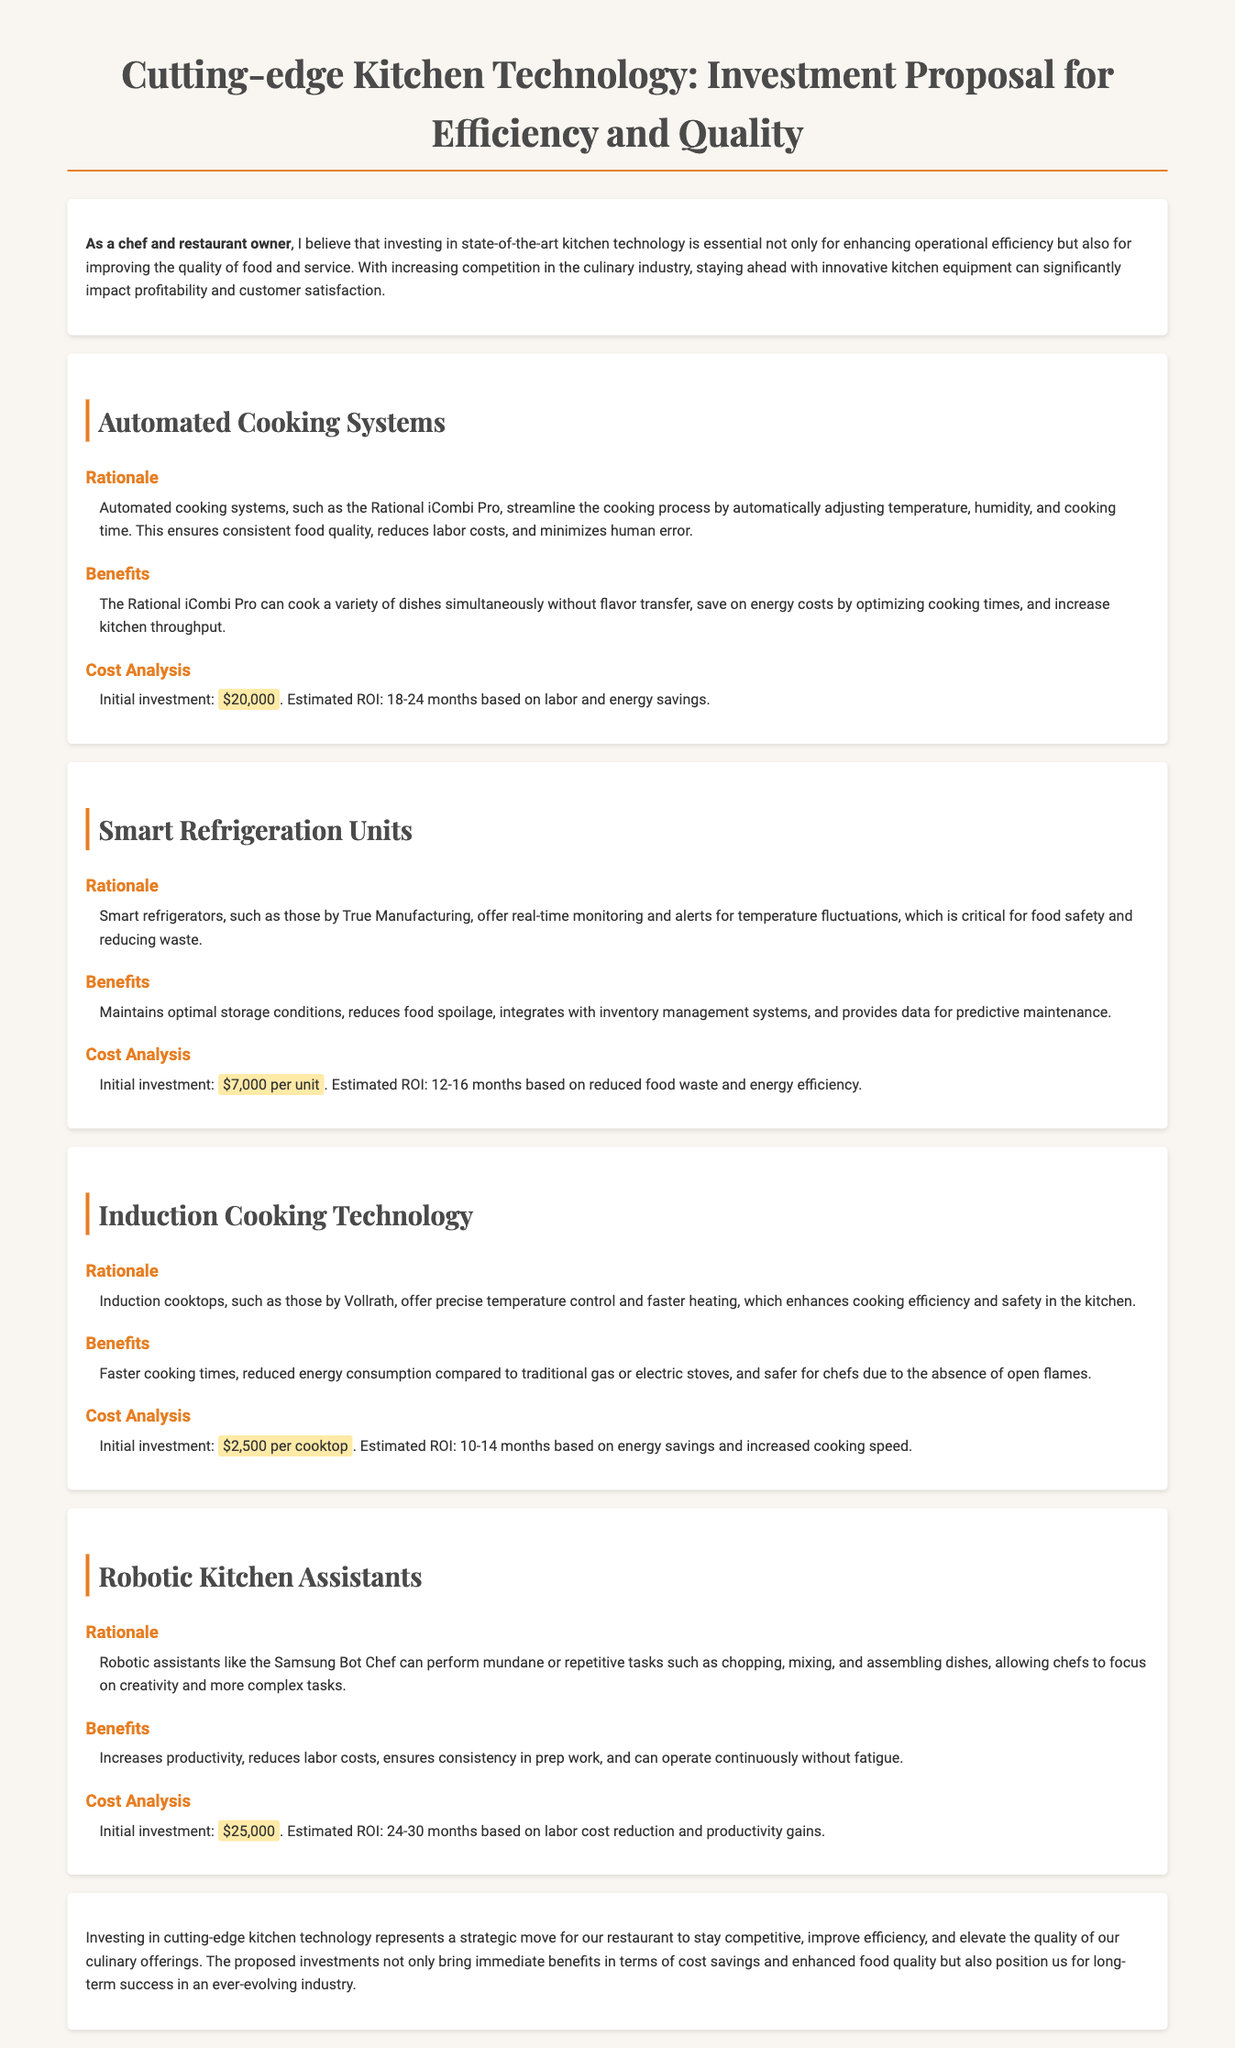What is the initial investment for the Rational iCombi Pro? The initial investment for the Rational iCombi Pro is mentioned under Cost Analysis in the document.
Answer: $20,000 What is the estimated ROI for Smart Refrigeration Units? The document provides the estimated ROI based on reduced food waste and energy efficiency.
Answer: 12-16 months What technology is suggested for automated cooking? The proposal specifically mentions the Rational iCombi Pro under Automated Cooking Systems.
Answer: Rational iCombi Pro What are the benefits of Induction Cooking Technology? The section on Induction Cooking Technology outlines the advantages, including energy consumption and cooking times.
Answer: Faster cooking times, reduced energy consumption, safer for chefs What is the initial investment for a single Induction cooktop? The Cost Analysis section specifies the investment required for each unit mentioned under Induction Cooking Technology.
Answer: $2,500 per cooktop Which robotic kitchen assistant is mentioned in the proposal? The document names a specific robotic assistant in the Robotic Kitchen Assistants section.
Answer: Samsung Bot Chef What is a primary rationale for using Smart Refrigeration Units? The rationale highlights the monitoring and alert capabilities for temperature fluctuations under the Smart Refrigeration Units section.
Answer: Real-time monitoring and alerts for temperature fluctuations What is the overall conclusion regarding investing in kitchen technology? The conclusion summarizes the strategic benefits of implementing advanced kitchen technology.
Answer: Strategic move for our restaurant to stay competitive 